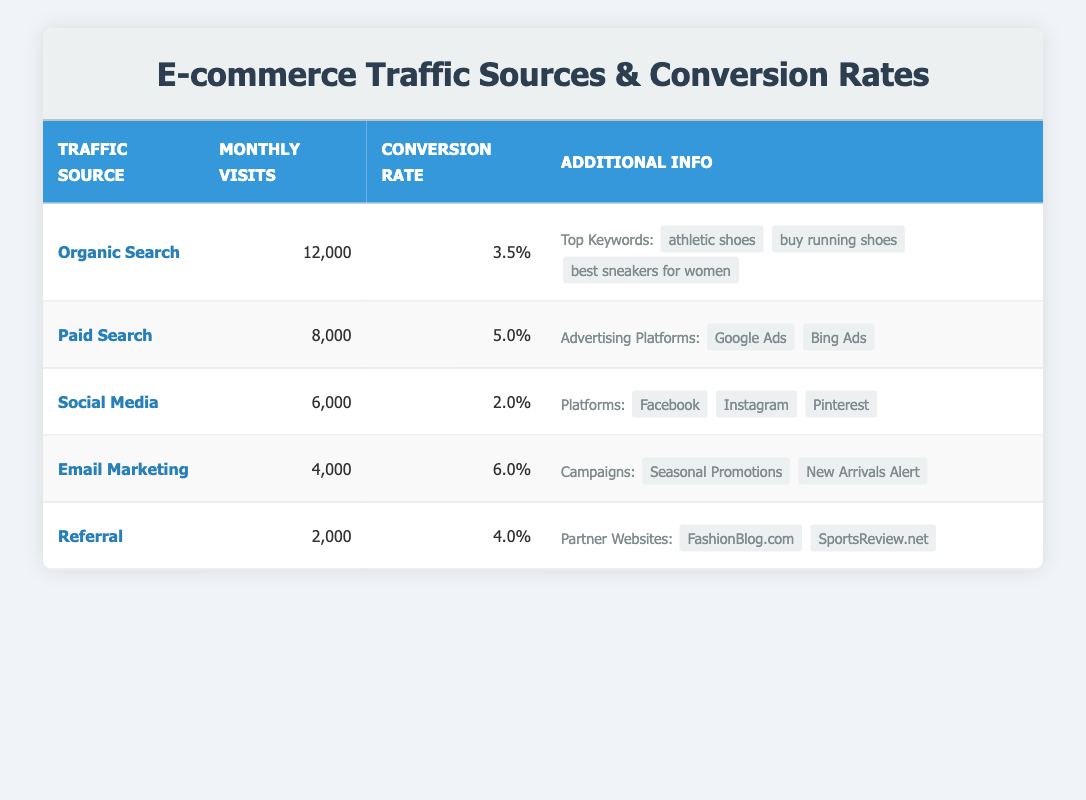What is the monthly visit count from Organic Search? The table shows that Organic Search has 12,000 monthly visits listed clearly under the "Monthly Visits" column.
Answer: 12,000 Which traffic source has the highest conversion rate? The conversion rates for all traffic sources are listed, with Email Marketing having the highest rate at 6.0% in the "Conversion Rate" column.
Answer: Email Marketing What is the average monthly visit count for all traffic sources? The total monthly visits from all sources are 12,000 (Organic Search) + 8,000 (Paid Search) + 6,000 (Social Media) + 4,000 (Email Marketing) + 2,000 (Referral) = 32,000. There are 5 traffic sources, so the average is 32,000 / 5 = 6,400.
Answer: 6,400 Is the conversion rate for Social Media higher than that for Paid Search? The conversion rate for Social Media is 2.0% while Paid Search has a conversion rate of 5.0%. Since 2.0% is less than 5.0%, the statement is false.
Answer: No Which traffic source contributes the least number of monthly visits? The table indicates Referral as contributing 2,000 monthly visits, which is the lowest among all the sources compared.
Answer: Referral 